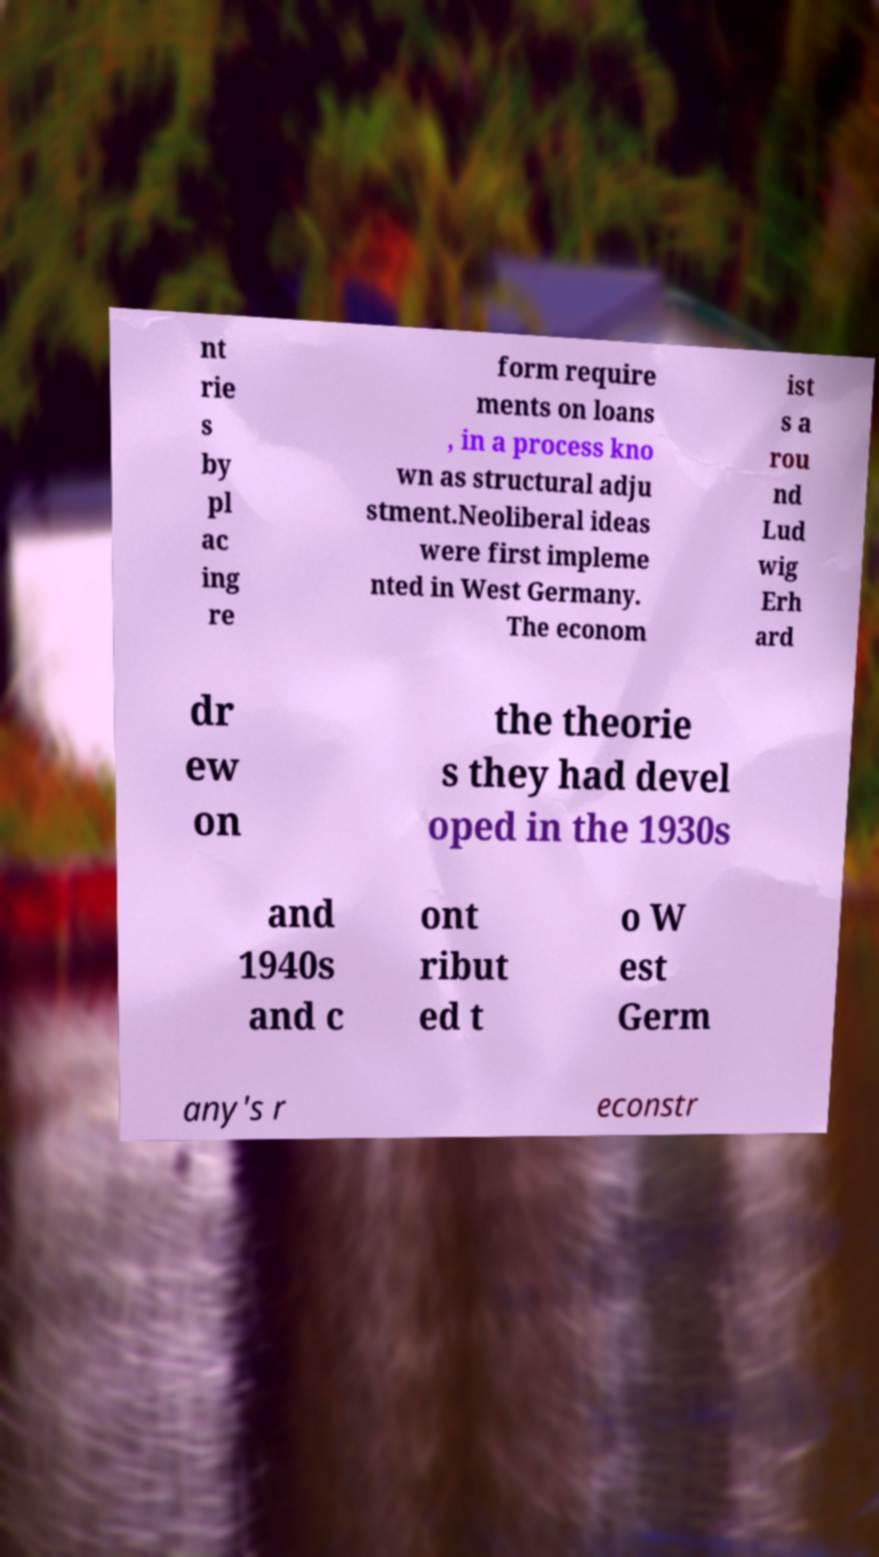What messages or text are displayed in this image? I need them in a readable, typed format. nt rie s by pl ac ing re form require ments on loans , in a process kno wn as structural adju stment.Neoliberal ideas were first impleme nted in West Germany. The econom ist s a rou nd Lud wig Erh ard dr ew on the theorie s they had devel oped in the 1930s and 1940s and c ont ribut ed t o W est Germ any's r econstr 